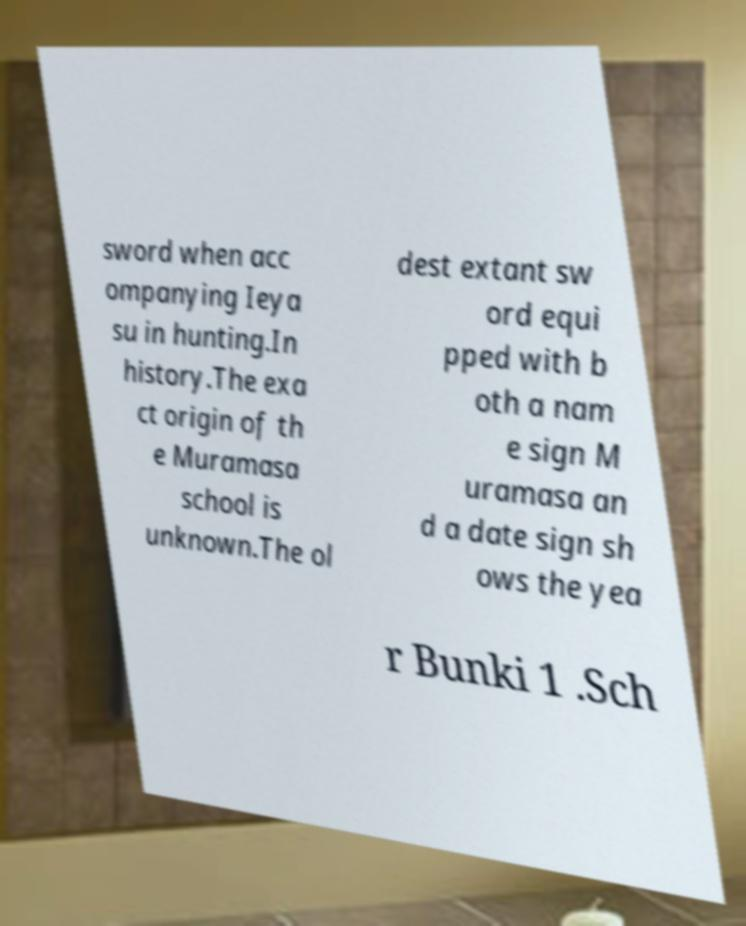Could you assist in decoding the text presented in this image and type it out clearly? sword when acc ompanying Ieya su in hunting.In history.The exa ct origin of th e Muramasa school is unknown.The ol dest extant sw ord equi pped with b oth a nam e sign M uramasa an d a date sign sh ows the yea r Bunki 1 .Sch 